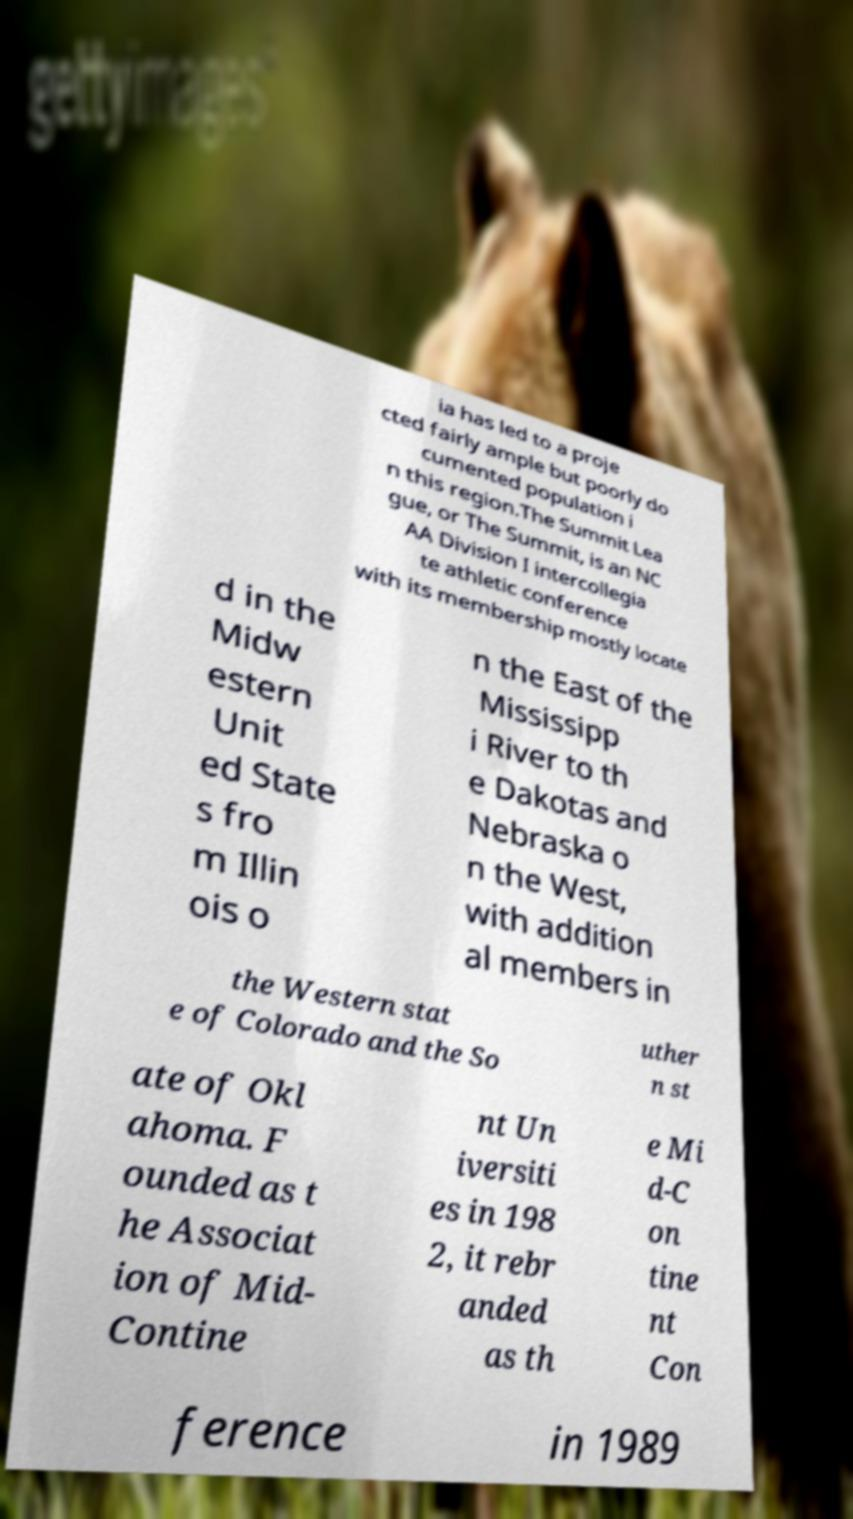What messages or text are displayed in this image? I need them in a readable, typed format. ia has led to a proje cted fairly ample but poorly do cumented population i n this region.The Summit Lea gue, or The Summit, is an NC AA Division I intercollegia te athletic conference with its membership mostly locate d in the Midw estern Unit ed State s fro m Illin ois o n the East of the Mississipp i River to th e Dakotas and Nebraska o n the West, with addition al members in the Western stat e of Colorado and the So uther n st ate of Okl ahoma. F ounded as t he Associat ion of Mid- Contine nt Un iversiti es in 198 2, it rebr anded as th e Mi d-C on tine nt Con ference in 1989 